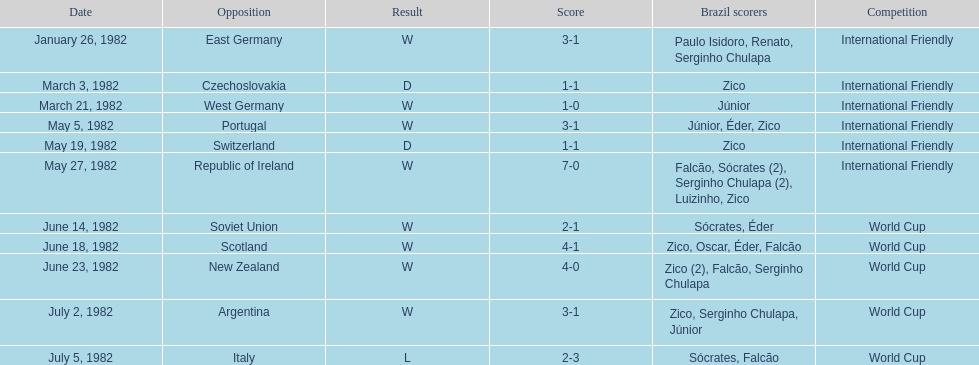Were there over 6 goals tallied on june 14, 1982? No. 